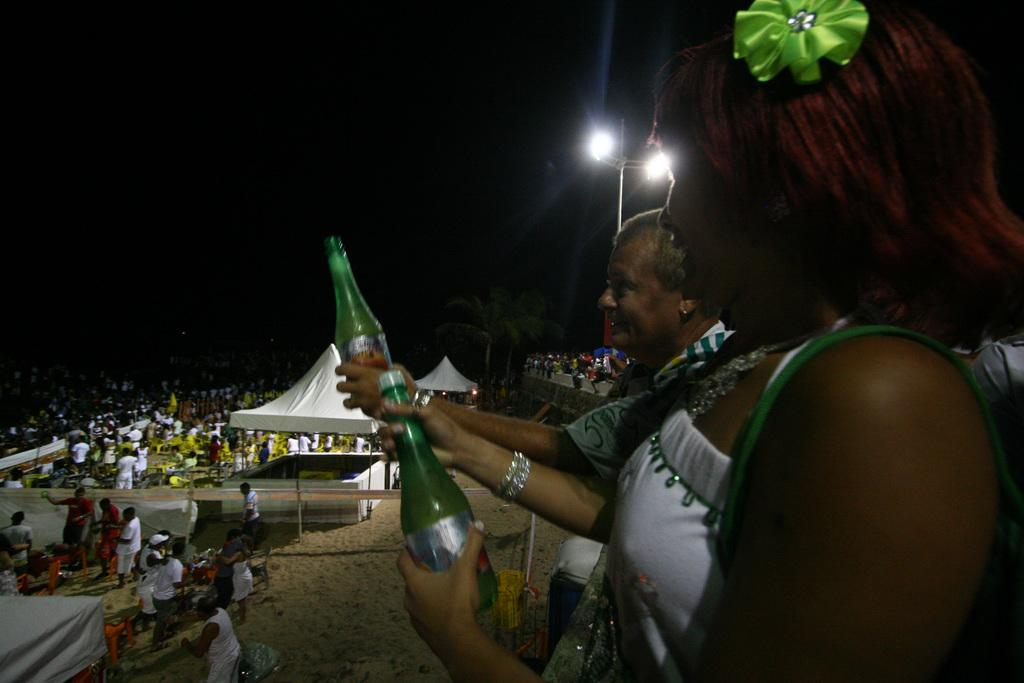How many people are in the image? There are many people in the image. What structure can be seen in the image? There is a tent in the image. What is another object visible in the image? There is a light pole in the image. What type of vegetation is present in the image? There is a tree in the image. What are the people holding in their hands? The people are holding bottles in their hands. What is the color of the sand in the image? The sand is in cream color. What type of stitch is being used to sew the attraction in the image? There is no attraction or stitching present in the image. How does the cough affect the people in the image? There is no cough or indication of illness in the image. 